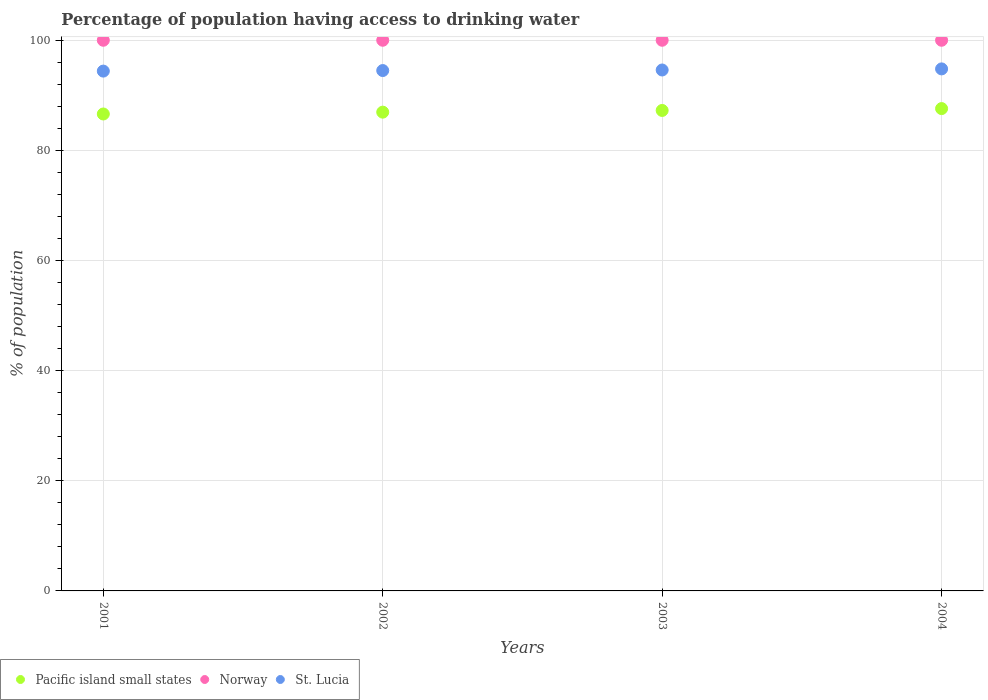How many different coloured dotlines are there?
Offer a very short reply. 3. What is the percentage of population having access to drinking water in Norway in 2003?
Make the answer very short. 100. Across all years, what is the maximum percentage of population having access to drinking water in St. Lucia?
Keep it short and to the point. 94.8. Across all years, what is the minimum percentage of population having access to drinking water in Pacific island small states?
Keep it short and to the point. 86.61. In which year was the percentage of population having access to drinking water in St. Lucia minimum?
Make the answer very short. 2001. What is the total percentage of population having access to drinking water in St. Lucia in the graph?
Offer a terse response. 378.3. What is the difference between the percentage of population having access to drinking water in St. Lucia in 2002 and that in 2004?
Your response must be concise. -0.3. What is the difference between the percentage of population having access to drinking water in St. Lucia in 2002 and the percentage of population having access to drinking water in Norway in 2003?
Your response must be concise. -5.5. What is the average percentage of population having access to drinking water in Pacific island small states per year?
Your response must be concise. 87.1. In the year 2004, what is the difference between the percentage of population having access to drinking water in Pacific island small states and percentage of population having access to drinking water in St. Lucia?
Provide a succinct answer. -7.21. In how many years, is the percentage of population having access to drinking water in Norway greater than 44 %?
Provide a short and direct response. 4. What is the ratio of the percentage of population having access to drinking water in St. Lucia in 2001 to that in 2002?
Give a very brief answer. 1. Is the percentage of population having access to drinking water in St. Lucia in 2003 less than that in 2004?
Your answer should be very brief. Yes. What is the difference between the highest and the second highest percentage of population having access to drinking water in Pacific island small states?
Ensure brevity in your answer.  0.34. What is the difference between the highest and the lowest percentage of population having access to drinking water in Pacific island small states?
Your answer should be compact. 0.98. Is the sum of the percentage of population having access to drinking water in Pacific island small states in 2001 and 2002 greater than the maximum percentage of population having access to drinking water in Norway across all years?
Keep it short and to the point. Yes. Is it the case that in every year, the sum of the percentage of population having access to drinking water in Pacific island small states and percentage of population having access to drinking water in Norway  is greater than the percentage of population having access to drinking water in St. Lucia?
Your answer should be very brief. Yes. Is the percentage of population having access to drinking water in Pacific island small states strictly less than the percentage of population having access to drinking water in Norway over the years?
Provide a short and direct response. Yes. What is the difference between two consecutive major ticks on the Y-axis?
Provide a short and direct response. 20. Does the graph contain any zero values?
Give a very brief answer. No. Does the graph contain grids?
Keep it short and to the point. Yes. Where does the legend appear in the graph?
Provide a succinct answer. Bottom left. How many legend labels are there?
Your answer should be compact. 3. How are the legend labels stacked?
Your answer should be very brief. Horizontal. What is the title of the graph?
Provide a succinct answer. Percentage of population having access to drinking water. What is the label or title of the Y-axis?
Keep it short and to the point. % of population. What is the % of population in Pacific island small states in 2001?
Offer a terse response. 86.61. What is the % of population of Norway in 2001?
Your answer should be compact. 100. What is the % of population in St. Lucia in 2001?
Provide a short and direct response. 94.4. What is the % of population of Pacific island small states in 2002?
Provide a short and direct response. 86.94. What is the % of population in Norway in 2002?
Give a very brief answer. 100. What is the % of population of St. Lucia in 2002?
Keep it short and to the point. 94.5. What is the % of population in Pacific island small states in 2003?
Your answer should be compact. 87.25. What is the % of population in Norway in 2003?
Your answer should be very brief. 100. What is the % of population in St. Lucia in 2003?
Give a very brief answer. 94.6. What is the % of population of Pacific island small states in 2004?
Your answer should be compact. 87.59. What is the % of population in St. Lucia in 2004?
Ensure brevity in your answer.  94.8. Across all years, what is the maximum % of population of Pacific island small states?
Keep it short and to the point. 87.59. Across all years, what is the maximum % of population of Norway?
Keep it short and to the point. 100. Across all years, what is the maximum % of population of St. Lucia?
Keep it short and to the point. 94.8. Across all years, what is the minimum % of population in Pacific island small states?
Offer a very short reply. 86.61. Across all years, what is the minimum % of population in Norway?
Keep it short and to the point. 100. Across all years, what is the minimum % of population of St. Lucia?
Offer a terse response. 94.4. What is the total % of population in Pacific island small states in the graph?
Ensure brevity in your answer.  348.4. What is the total % of population in Norway in the graph?
Give a very brief answer. 400. What is the total % of population in St. Lucia in the graph?
Make the answer very short. 378.3. What is the difference between the % of population in Pacific island small states in 2001 and that in 2002?
Your answer should be very brief. -0.33. What is the difference between the % of population of Norway in 2001 and that in 2002?
Your answer should be very brief. 0. What is the difference between the % of population of St. Lucia in 2001 and that in 2002?
Provide a short and direct response. -0.1. What is the difference between the % of population of Pacific island small states in 2001 and that in 2003?
Offer a terse response. -0.64. What is the difference between the % of population in Norway in 2001 and that in 2003?
Offer a terse response. 0. What is the difference between the % of population in St. Lucia in 2001 and that in 2003?
Provide a short and direct response. -0.2. What is the difference between the % of population in Pacific island small states in 2001 and that in 2004?
Give a very brief answer. -0.98. What is the difference between the % of population in Pacific island small states in 2002 and that in 2003?
Ensure brevity in your answer.  -0.31. What is the difference between the % of population in St. Lucia in 2002 and that in 2003?
Your response must be concise. -0.1. What is the difference between the % of population in Pacific island small states in 2002 and that in 2004?
Your answer should be compact. -0.65. What is the difference between the % of population in Norway in 2002 and that in 2004?
Offer a terse response. 0. What is the difference between the % of population in St. Lucia in 2002 and that in 2004?
Provide a succinct answer. -0.3. What is the difference between the % of population in Pacific island small states in 2003 and that in 2004?
Ensure brevity in your answer.  -0.34. What is the difference between the % of population in St. Lucia in 2003 and that in 2004?
Offer a very short reply. -0.2. What is the difference between the % of population of Pacific island small states in 2001 and the % of population of Norway in 2002?
Give a very brief answer. -13.39. What is the difference between the % of population of Pacific island small states in 2001 and the % of population of St. Lucia in 2002?
Make the answer very short. -7.89. What is the difference between the % of population of Pacific island small states in 2001 and the % of population of Norway in 2003?
Your answer should be very brief. -13.39. What is the difference between the % of population of Pacific island small states in 2001 and the % of population of St. Lucia in 2003?
Your response must be concise. -7.99. What is the difference between the % of population of Norway in 2001 and the % of population of St. Lucia in 2003?
Your answer should be compact. 5.4. What is the difference between the % of population of Pacific island small states in 2001 and the % of population of Norway in 2004?
Ensure brevity in your answer.  -13.39. What is the difference between the % of population of Pacific island small states in 2001 and the % of population of St. Lucia in 2004?
Ensure brevity in your answer.  -8.19. What is the difference between the % of population in Pacific island small states in 2002 and the % of population in Norway in 2003?
Your answer should be very brief. -13.06. What is the difference between the % of population of Pacific island small states in 2002 and the % of population of St. Lucia in 2003?
Ensure brevity in your answer.  -7.66. What is the difference between the % of population in Pacific island small states in 2002 and the % of population in Norway in 2004?
Your response must be concise. -13.06. What is the difference between the % of population in Pacific island small states in 2002 and the % of population in St. Lucia in 2004?
Make the answer very short. -7.86. What is the difference between the % of population in Pacific island small states in 2003 and the % of population in Norway in 2004?
Your response must be concise. -12.75. What is the difference between the % of population of Pacific island small states in 2003 and the % of population of St. Lucia in 2004?
Provide a succinct answer. -7.55. What is the difference between the % of population in Norway in 2003 and the % of population in St. Lucia in 2004?
Provide a short and direct response. 5.2. What is the average % of population in Pacific island small states per year?
Give a very brief answer. 87.1. What is the average % of population of St. Lucia per year?
Your answer should be very brief. 94.58. In the year 2001, what is the difference between the % of population in Pacific island small states and % of population in Norway?
Provide a succinct answer. -13.39. In the year 2001, what is the difference between the % of population of Pacific island small states and % of population of St. Lucia?
Offer a terse response. -7.79. In the year 2002, what is the difference between the % of population of Pacific island small states and % of population of Norway?
Provide a short and direct response. -13.06. In the year 2002, what is the difference between the % of population of Pacific island small states and % of population of St. Lucia?
Offer a very short reply. -7.56. In the year 2002, what is the difference between the % of population in Norway and % of population in St. Lucia?
Provide a short and direct response. 5.5. In the year 2003, what is the difference between the % of population in Pacific island small states and % of population in Norway?
Provide a succinct answer. -12.75. In the year 2003, what is the difference between the % of population of Pacific island small states and % of population of St. Lucia?
Your answer should be compact. -7.35. In the year 2004, what is the difference between the % of population of Pacific island small states and % of population of Norway?
Your answer should be very brief. -12.41. In the year 2004, what is the difference between the % of population of Pacific island small states and % of population of St. Lucia?
Provide a succinct answer. -7.21. What is the ratio of the % of population of Pacific island small states in 2001 to that in 2002?
Provide a succinct answer. 1. What is the ratio of the % of population of Norway in 2001 to that in 2003?
Ensure brevity in your answer.  1. What is the ratio of the % of population in Pacific island small states in 2001 to that in 2004?
Your answer should be very brief. 0.99. What is the ratio of the % of population of Norway in 2001 to that in 2004?
Provide a short and direct response. 1. What is the ratio of the % of population of Pacific island small states in 2002 to that in 2003?
Your response must be concise. 1. What is the ratio of the % of population in Norway in 2002 to that in 2003?
Offer a terse response. 1. What is the ratio of the % of population of St. Lucia in 2002 to that in 2003?
Your answer should be compact. 1. What is the ratio of the % of population in Pacific island small states in 2002 to that in 2004?
Provide a short and direct response. 0.99. What is the ratio of the % of population in Norway in 2002 to that in 2004?
Provide a short and direct response. 1. What is the ratio of the % of population in Pacific island small states in 2003 to that in 2004?
Your response must be concise. 1. What is the difference between the highest and the second highest % of population of Pacific island small states?
Provide a succinct answer. 0.34. What is the difference between the highest and the lowest % of population of Pacific island small states?
Offer a terse response. 0.98. What is the difference between the highest and the lowest % of population of St. Lucia?
Provide a short and direct response. 0.4. 